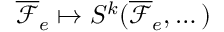<formula> <loc_0><loc_0><loc_500><loc_500>\overline { \mathcal { F } } _ { e } \mapsto S ^ { k } ( \overline { \mathcal { F } } _ { e } , \dots )</formula> 